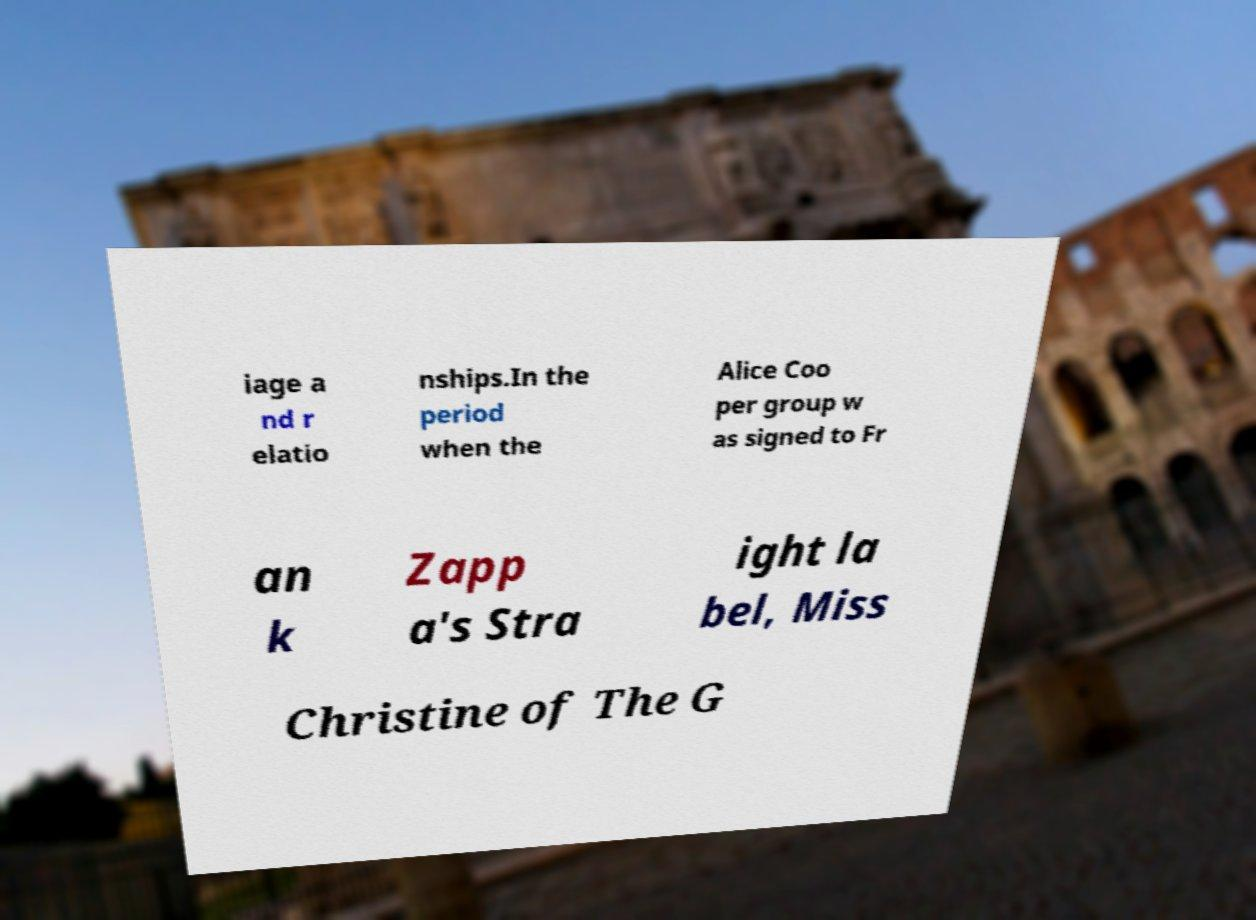Can you accurately transcribe the text from the provided image for me? iage a nd r elatio nships.In the period when the Alice Coo per group w as signed to Fr an k Zapp a's Stra ight la bel, Miss Christine of The G 